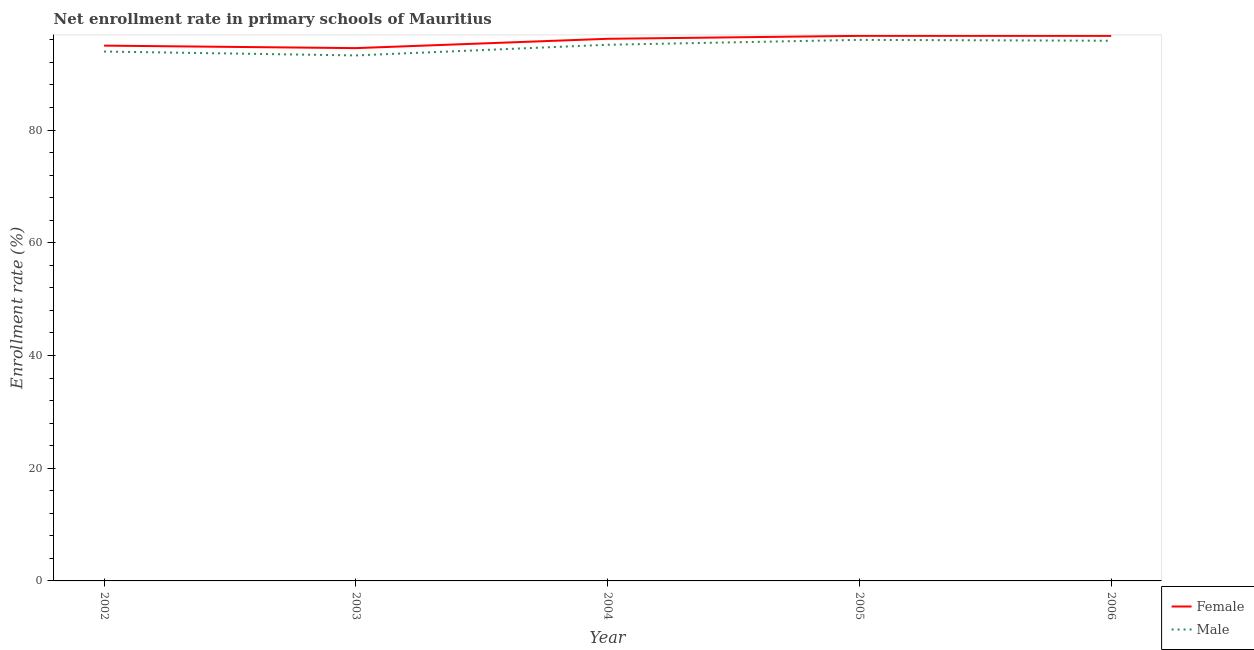How many different coloured lines are there?
Your response must be concise. 2. Does the line corresponding to enrollment rate of female students intersect with the line corresponding to enrollment rate of male students?
Offer a terse response. No. What is the enrollment rate of female students in 2003?
Provide a short and direct response. 94.53. Across all years, what is the maximum enrollment rate of male students?
Give a very brief answer. 96. Across all years, what is the minimum enrollment rate of male students?
Your response must be concise. 93.24. In which year was the enrollment rate of female students minimum?
Your answer should be compact. 2003. What is the total enrollment rate of female students in the graph?
Your answer should be very brief. 479.12. What is the difference between the enrollment rate of female students in 2002 and that in 2006?
Make the answer very short. -1.73. What is the difference between the enrollment rate of female students in 2005 and the enrollment rate of male students in 2003?
Your answer should be compact. 3.47. What is the average enrollment rate of female students per year?
Provide a short and direct response. 95.82. In the year 2002, what is the difference between the enrollment rate of female students and enrollment rate of male students?
Ensure brevity in your answer.  1.05. What is the ratio of the enrollment rate of female students in 2002 to that in 2005?
Offer a very short reply. 0.98. What is the difference between the highest and the second highest enrollment rate of female students?
Keep it short and to the point. 0. What is the difference between the highest and the lowest enrollment rate of female students?
Offer a very short reply. 2.18. In how many years, is the enrollment rate of female students greater than the average enrollment rate of female students taken over all years?
Offer a terse response. 3. Is the sum of the enrollment rate of female students in 2003 and 2005 greater than the maximum enrollment rate of male students across all years?
Ensure brevity in your answer.  Yes. Does the enrollment rate of male students monotonically increase over the years?
Ensure brevity in your answer.  No. Is the enrollment rate of female students strictly greater than the enrollment rate of male students over the years?
Offer a terse response. Yes. Is the enrollment rate of female students strictly less than the enrollment rate of male students over the years?
Offer a terse response. No. How many lines are there?
Your answer should be compact. 2. How many years are there in the graph?
Make the answer very short. 5. Are the values on the major ticks of Y-axis written in scientific E-notation?
Your answer should be very brief. No. Where does the legend appear in the graph?
Offer a very short reply. Bottom right. How are the legend labels stacked?
Provide a succinct answer. Vertical. What is the title of the graph?
Offer a terse response. Net enrollment rate in primary schools of Mauritius. What is the label or title of the X-axis?
Your answer should be compact. Year. What is the label or title of the Y-axis?
Keep it short and to the point. Enrollment rate (%). What is the Enrollment rate (%) of Female in 2002?
Keep it short and to the point. 94.98. What is the Enrollment rate (%) of Male in 2002?
Keep it short and to the point. 93.93. What is the Enrollment rate (%) in Female in 2003?
Give a very brief answer. 94.53. What is the Enrollment rate (%) in Male in 2003?
Make the answer very short. 93.24. What is the Enrollment rate (%) in Female in 2004?
Provide a short and direct response. 96.19. What is the Enrollment rate (%) in Male in 2004?
Your answer should be compact. 95.13. What is the Enrollment rate (%) in Female in 2005?
Offer a very short reply. 96.71. What is the Enrollment rate (%) of Male in 2005?
Ensure brevity in your answer.  96. What is the Enrollment rate (%) of Female in 2006?
Offer a very short reply. 96.71. What is the Enrollment rate (%) of Male in 2006?
Keep it short and to the point. 95.84. Across all years, what is the maximum Enrollment rate (%) in Female?
Your answer should be compact. 96.71. Across all years, what is the maximum Enrollment rate (%) in Male?
Keep it short and to the point. 96. Across all years, what is the minimum Enrollment rate (%) in Female?
Provide a succinct answer. 94.53. Across all years, what is the minimum Enrollment rate (%) in Male?
Ensure brevity in your answer.  93.24. What is the total Enrollment rate (%) in Female in the graph?
Provide a succinct answer. 479.12. What is the total Enrollment rate (%) in Male in the graph?
Ensure brevity in your answer.  474.14. What is the difference between the Enrollment rate (%) of Female in 2002 and that in 2003?
Keep it short and to the point. 0.44. What is the difference between the Enrollment rate (%) in Male in 2002 and that in 2003?
Offer a terse response. 0.69. What is the difference between the Enrollment rate (%) of Female in 2002 and that in 2004?
Ensure brevity in your answer.  -1.21. What is the difference between the Enrollment rate (%) of Male in 2002 and that in 2004?
Provide a succinct answer. -1.2. What is the difference between the Enrollment rate (%) of Female in 2002 and that in 2005?
Offer a very short reply. -1.73. What is the difference between the Enrollment rate (%) in Male in 2002 and that in 2005?
Make the answer very short. -2.07. What is the difference between the Enrollment rate (%) of Female in 2002 and that in 2006?
Your answer should be very brief. -1.73. What is the difference between the Enrollment rate (%) in Male in 2002 and that in 2006?
Offer a terse response. -1.92. What is the difference between the Enrollment rate (%) of Female in 2003 and that in 2004?
Give a very brief answer. -1.66. What is the difference between the Enrollment rate (%) in Male in 2003 and that in 2004?
Ensure brevity in your answer.  -1.89. What is the difference between the Enrollment rate (%) of Female in 2003 and that in 2005?
Ensure brevity in your answer.  -2.18. What is the difference between the Enrollment rate (%) of Male in 2003 and that in 2005?
Make the answer very short. -2.76. What is the difference between the Enrollment rate (%) of Female in 2003 and that in 2006?
Keep it short and to the point. -2.17. What is the difference between the Enrollment rate (%) of Male in 2003 and that in 2006?
Offer a very short reply. -2.61. What is the difference between the Enrollment rate (%) of Female in 2004 and that in 2005?
Your answer should be compact. -0.52. What is the difference between the Enrollment rate (%) in Male in 2004 and that in 2005?
Offer a very short reply. -0.87. What is the difference between the Enrollment rate (%) of Female in 2004 and that in 2006?
Your answer should be very brief. -0.52. What is the difference between the Enrollment rate (%) of Male in 2004 and that in 2006?
Keep it short and to the point. -0.71. What is the difference between the Enrollment rate (%) in Female in 2005 and that in 2006?
Your answer should be very brief. 0. What is the difference between the Enrollment rate (%) in Male in 2005 and that in 2006?
Provide a short and direct response. 0.15. What is the difference between the Enrollment rate (%) of Female in 2002 and the Enrollment rate (%) of Male in 2003?
Give a very brief answer. 1.74. What is the difference between the Enrollment rate (%) in Female in 2002 and the Enrollment rate (%) in Male in 2004?
Make the answer very short. -0.15. What is the difference between the Enrollment rate (%) of Female in 2002 and the Enrollment rate (%) of Male in 2005?
Make the answer very short. -1.02. What is the difference between the Enrollment rate (%) of Female in 2002 and the Enrollment rate (%) of Male in 2006?
Keep it short and to the point. -0.87. What is the difference between the Enrollment rate (%) of Female in 2003 and the Enrollment rate (%) of Male in 2004?
Keep it short and to the point. -0.6. What is the difference between the Enrollment rate (%) of Female in 2003 and the Enrollment rate (%) of Male in 2005?
Keep it short and to the point. -1.46. What is the difference between the Enrollment rate (%) of Female in 2003 and the Enrollment rate (%) of Male in 2006?
Offer a very short reply. -1.31. What is the difference between the Enrollment rate (%) of Female in 2004 and the Enrollment rate (%) of Male in 2005?
Offer a very short reply. 0.19. What is the difference between the Enrollment rate (%) of Female in 2004 and the Enrollment rate (%) of Male in 2006?
Your answer should be compact. 0.35. What is the difference between the Enrollment rate (%) in Female in 2005 and the Enrollment rate (%) in Male in 2006?
Provide a succinct answer. 0.87. What is the average Enrollment rate (%) of Female per year?
Your response must be concise. 95.83. What is the average Enrollment rate (%) in Male per year?
Give a very brief answer. 94.83. In the year 2002, what is the difference between the Enrollment rate (%) in Female and Enrollment rate (%) in Male?
Give a very brief answer. 1.05. In the year 2003, what is the difference between the Enrollment rate (%) in Female and Enrollment rate (%) in Male?
Your answer should be compact. 1.3. In the year 2004, what is the difference between the Enrollment rate (%) of Female and Enrollment rate (%) of Male?
Provide a succinct answer. 1.06. In the year 2005, what is the difference between the Enrollment rate (%) in Female and Enrollment rate (%) in Male?
Your answer should be very brief. 0.71. In the year 2006, what is the difference between the Enrollment rate (%) in Female and Enrollment rate (%) in Male?
Your answer should be compact. 0.86. What is the ratio of the Enrollment rate (%) of Male in 2002 to that in 2003?
Provide a succinct answer. 1.01. What is the ratio of the Enrollment rate (%) in Female in 2002 to that in 2004?
Ensure brevity in your answer.  0.99. What is the ratio of the Enrollment rate (%) in Male in 2002 to that in 2004?
Provide a succinct answer. 0.99. What is the ratio of the Enrollment rate (%) in Female in 2002 to that in 2005?
Offer a terse response. 0.98. What is the ratio of the Enrollment rate (%) of Male in 2002 to that in 2005?
Offer a terse response. 0.98. What is the ratio of the Enrollment rate (%) in Female in 2002 to that in 2006?
Your response must be concise. 0.98. What is the ratio of the Enrollment rate (%) of Male in 2002 to that in 2006?
Your answer should be compact. 0.98. What is the ratio of the Enrollment rate (%) of Female in 2003 to that in 2004?
Offer a terse response. 0.98. What is the ratio of the Enrollment rate (%) of Male in 2003 to that in 2004?
Provide a succinct answer. 0.98. What is the ratio of the Enrollment rate (%) of Female in 2003 to that in 2005?
Make the answer very short. 0.98. What is the ratio of the Enrollment rate (%) of Male in 2003 to that in 2005?
Offer a terse response. 0.97. What is the ratio of the Enrollment rate (%) of Female in 2003 to that in 2006?
Provide a succinct answer. 0.98. What is the ratio of the Enrollment rate (%) in Male in 2003 to that in 2006?
Your response must be concise. 0.97. What is the ratio of the Enrollment rate (%) in Male in 2004 to that in 2005?
Offer a very short reply. 0.99. What is the ratio of the Enrollment rate (%) of Male in 2004 to that in 2006?
Give a very brief answer. 0.99. What is the ratio of the Enrollment rate (%) in Male in 2005 to that in 2006?
Your answer should be very brief. 1. What is the difference between the highest and the second highest Enrollment rate (%) in Female?
Your answer should be very brief. 0. What is the difference between the highest and the second highest Enrollment rate (%) in Male?
Provide a succinct answer. 0.15. What is the difference between the highest and the lowest Enrollment rate (%) in Female?
Keep it short and to the point. 2.18. What is the difference between the highest and the lowest Enrollment rate (%) of Male?
Your answer should be compact. 2.76. 